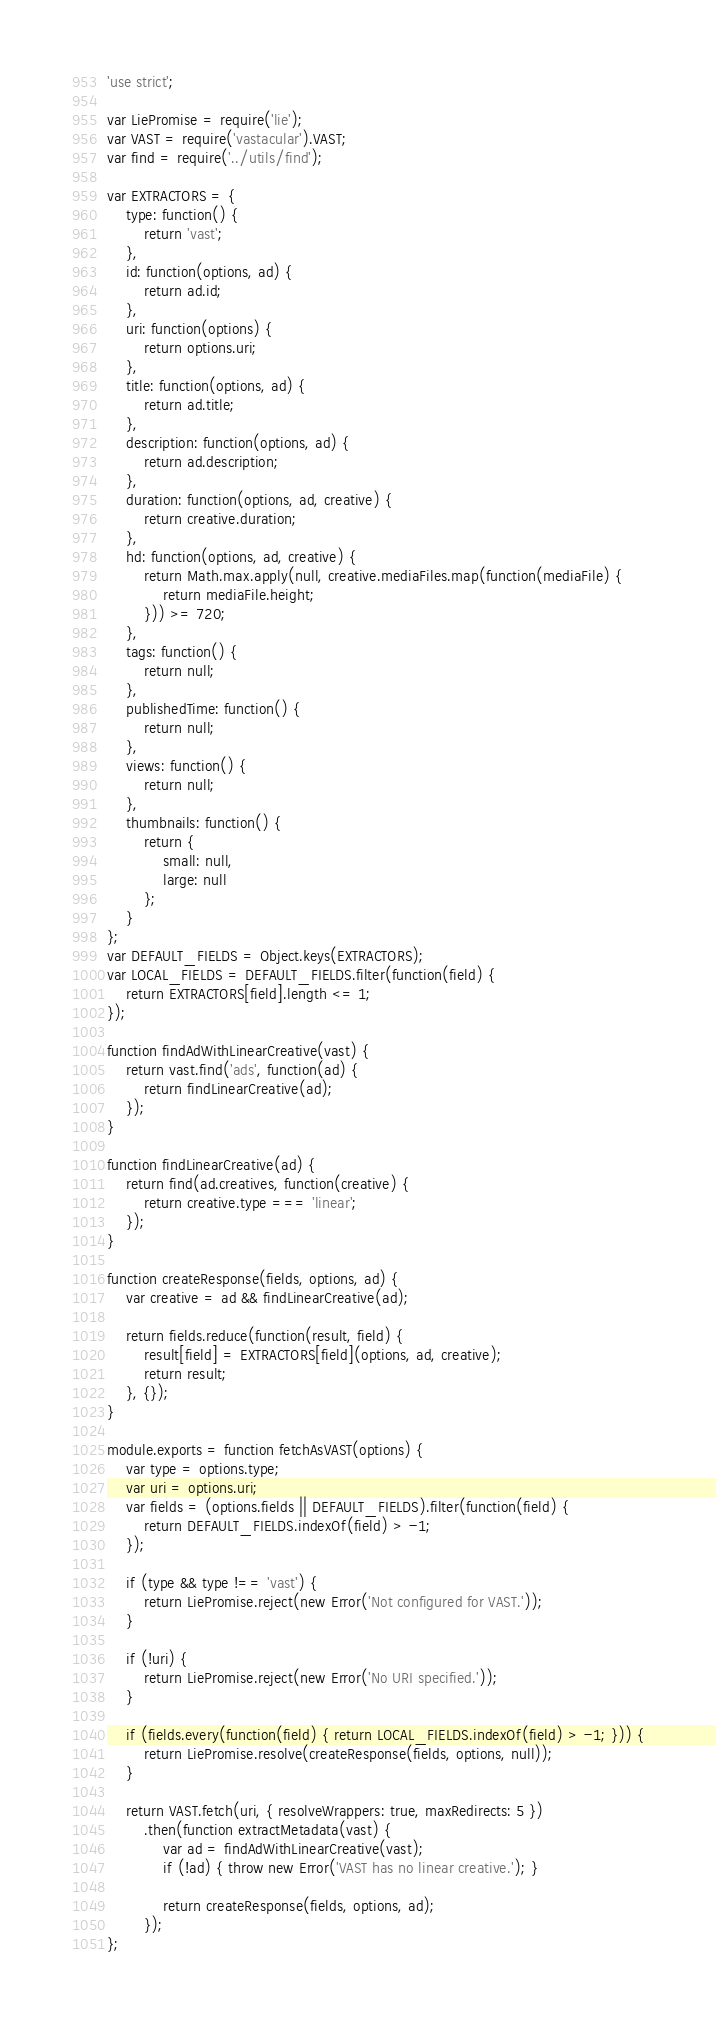<code> <loc_0><loc_0><loc_500><loc_500><_JavaScript_>'use strict';

var LiePromise = require('lie');
var VAST = require('vastacular').VAST;
var find = require('../utils/find');

var EXTRACTORS = {
    type: function() {
        return 'vast';
    },
    id: function(options, ad) {
        return ad.id;
    },
    uri: function(options) {
        return options.uri;
    },
    title: function(options, ad) {
        return ad.title;
    },
    description: function(options, ad) {
        return ad.description;
    },
    duration: function(options, ad, creative) {
        return creative.duration;
    },
    hd: function(options, ad, creative) {
        return Math.max.apply(null, creative.mediaFiles.map(function(mediaFile) {
            return mediaFile.height;
        })) >= 720;
    },
    tags: function() {
        return null;
    },
    publishedTime: function() {
        return null;
    },
    views: function() {
        return null;
    },
    thumbnails: function() {
        return {
            small: null,
            large: null
        };
    }
};
var DEFAULT_FIELDS = Object.keys(EXTRACTORS);
var LOCAL_FIELDS = DEFAULT_FIELDS.filter(function(field) {
    return EXTRACTORS[field].length <= 1;
});

function findAdWithLinearCreative(vast) {
    return vast.find('ads', function(ad) {
        return findLinearCreative(ad);
    });
}

function findLinearCreative(ad) {
    return find(ad.creatives, function(creative) {
        return creative.type === 'linear';
    });
}

function createResponse(fields, options, ad) {
    var creative = ad && findLinearCreative(ad);

    return fields.reduce(function(result, field) {
        result[field] = EXTRACTORS[field](options, ad, creative);
        return result;
    }, {});
}

module.exports = function fetchAsVAST(options) {
    var type = options.type;
    var uri = options.uri;
    var fields = (options.fields || DEFAULT_FIELDS).filter(function(field) {
        return DEFAULT_FIELDS.indexOf(field) > -1;
    });

    if (type && type !== 'vast') {
        return LiePromise.reject(new Error('Not configured for VAST.'));
    }

    if (!uri) {
        return LiePromise.reject(new Error('No URI specified.'));
    }

    if (fields.every(function(field) { return LOCAL_FIELDS.indexOf(field) > -1; })) {
        return LiePromise.resolve(createResponse(fields, options, null));
    }

    return VAST.fetch(uri, { resolveWrappers: true, maxRedirects: 5 })
        .then(function extractMetadata(vast) {
            var ad = findAdWithLinearCreative(vast);
            if (!ad) { throw new Error('VAST has no linear creative.'); }

            return createResponse(fields, options, ad);
        });
};
</code> 